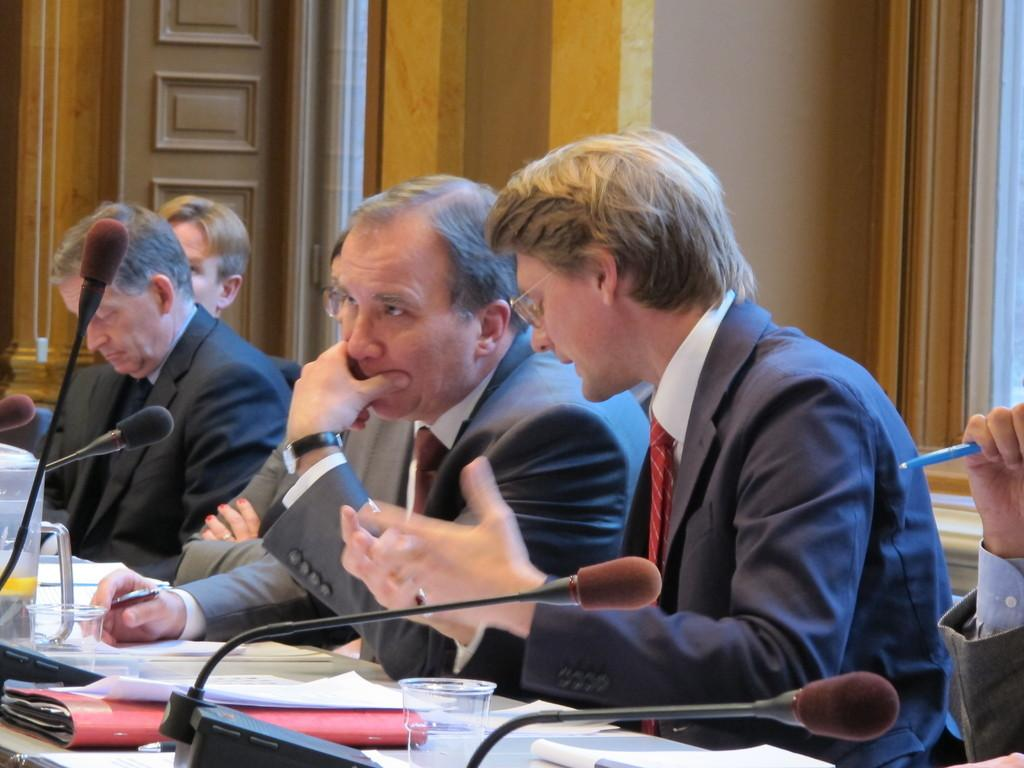How many people are in the image? There are people in the image, but the exact number is not specified. What are the people wearing? The people in the image are wearing suits. What items can be seen on the table? Papers, glasses, a file, and microphones (mics) are on the table. What is the background of the image like? There is a wall and a door in the background. What is one person holding in the image? One person is holding a pen. What type of camera is being used to take the picture? There is no information about a camera being used to take the picture, as the focus is on the people, their attire, and the items on the table. 